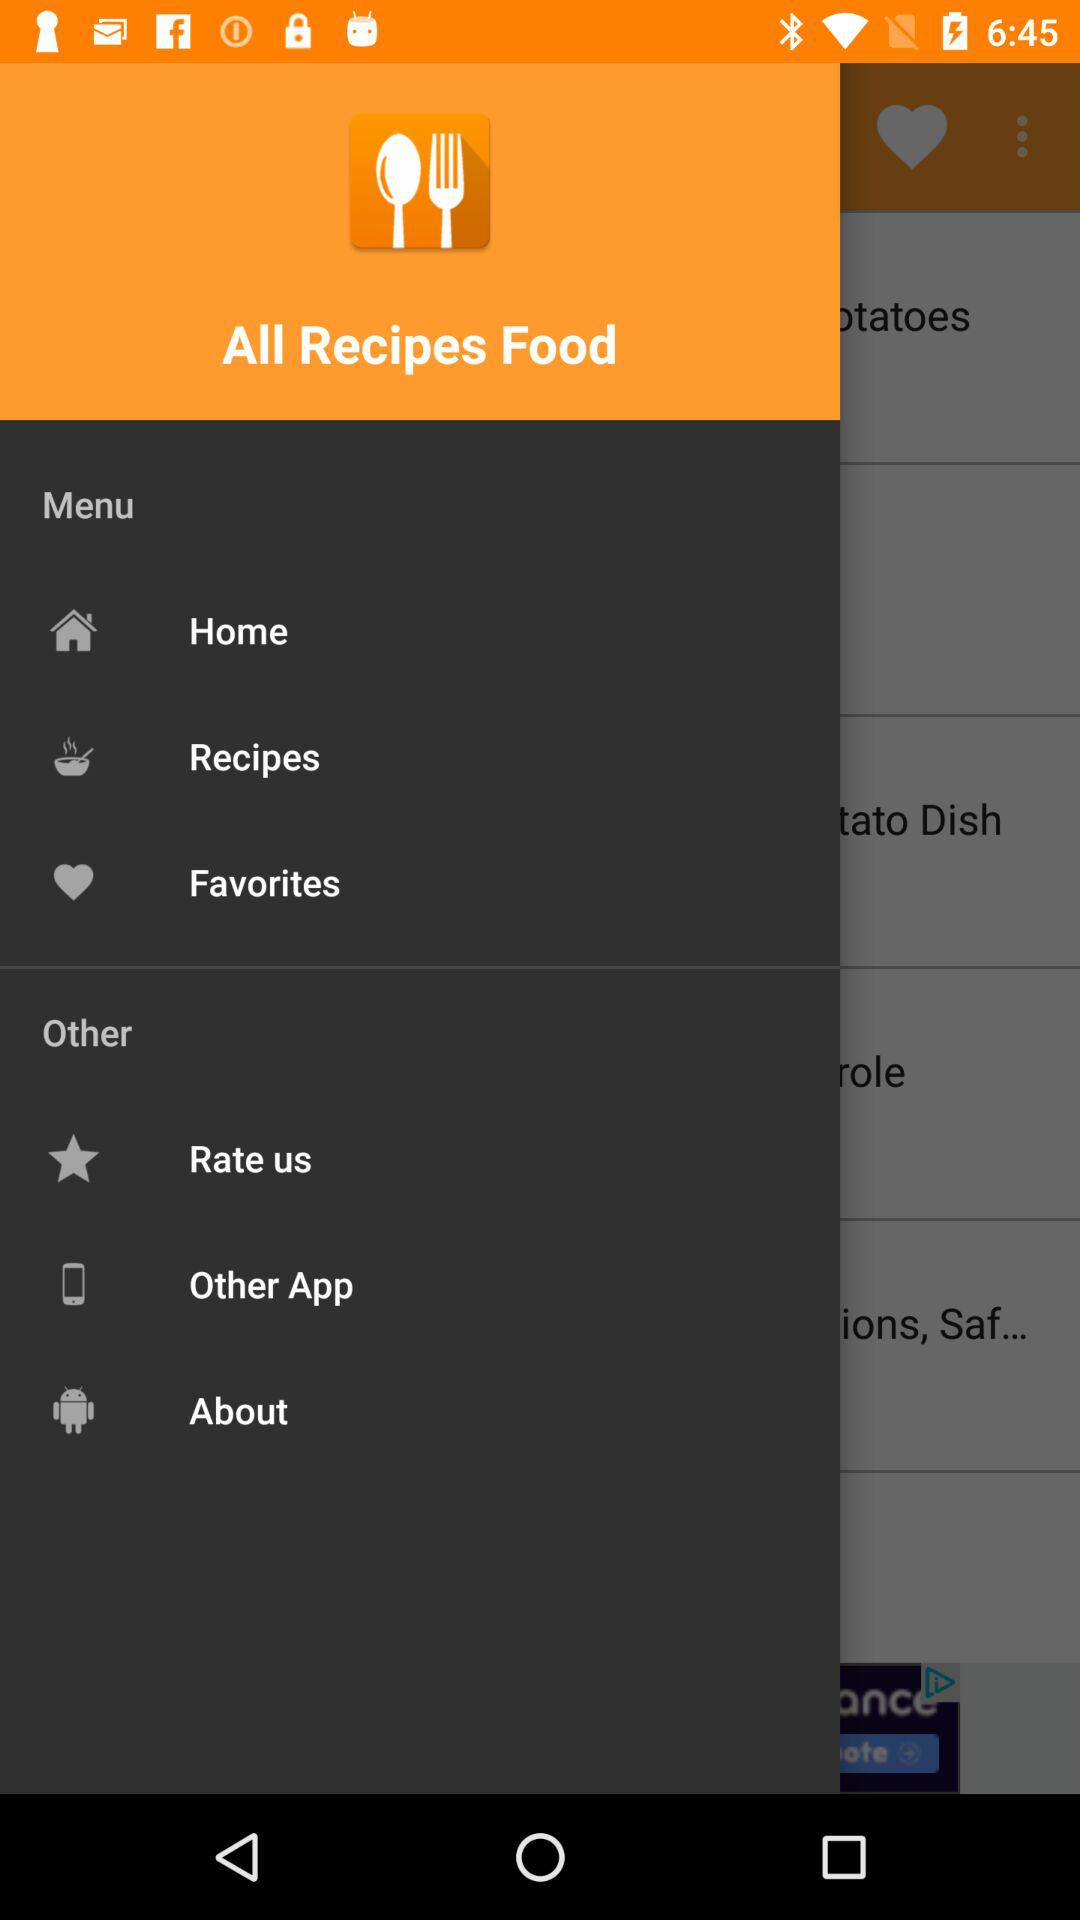Which recipes are saved?
When the provided information is insufficient, respond with <no answer>. <no answer> 